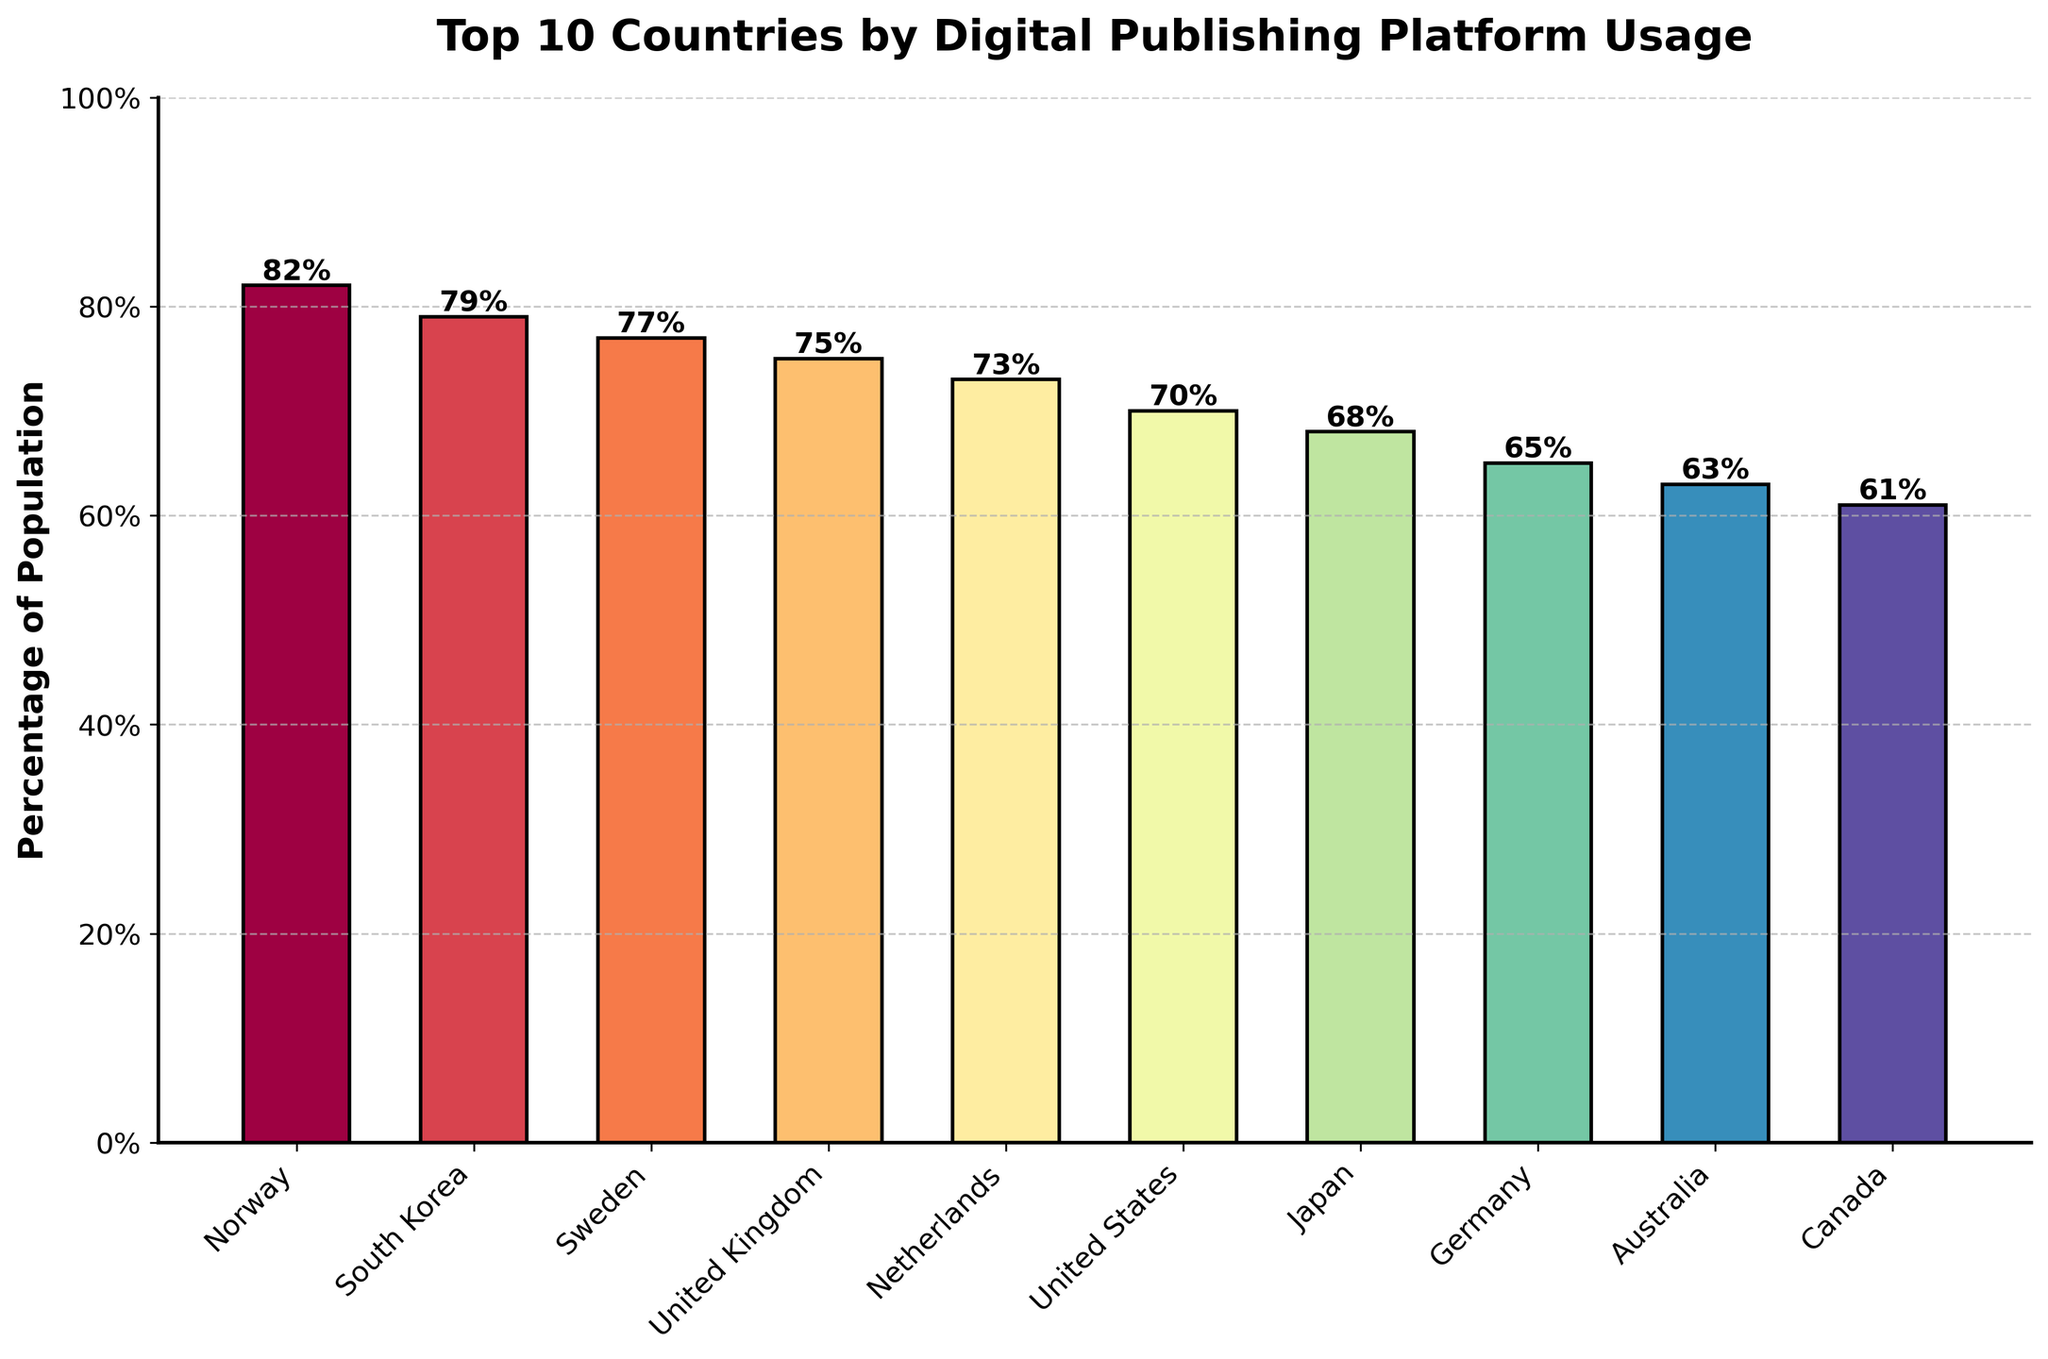What is the percentage of Norway's population using digital publishing platforms? The bar representing Norway's population usage is the tallest and is labeled with a percentage of 82%.
Answer: 82% What is the difference in digital publishing platform usage between Norway and Canada? Norway has a percentage of 82%, and Canada has 61%. The difference is calculated as 82% - 61% = 21%.
Answer: 21% Which country has the lowest percentage of population using digital publishing platforms? By observing the shortest bar, we see it corresponds to Canada with a percentage of 61%.
Answer: Canada Are there more countries with a usage percentage above 70% or below 70%? List the countries above 70%: Norway, South Korea, Sweden, United Kingdom, Netherlands, United States (6 countries). List the countries below 70%: Japan, Germany, Australia, Canada (4 countries). There are more countries above 70%.
Answer: Above 70% How many countries have a digital publishing platform usage between 60% and 80%? By examining the bar lengths and labels, countries with usage percentages between 60% and 80% are South Korea, Sweden, United Kingdom, Netherlands, United States, Japan, Germany, and Australia (8 countries).
Answer: 8 What is the average percentage of population using digital publishing platforms among the top 3 countries? The top 3 countries are Norway (82%), South Korea (79%), and Sweden (77%). Sum these percentages: 82 + 79 + 77 = 238. Calculate the average: 238 / 3 ≈ 79.33.
Answer: 79.33 Which country has a higher digital publishing platform usage, Germany or Australia? By comparing the bars and labels, Germany has 65% while Australia has 63%. Therefore, Germany has a higher usage percentage.
Answer: Germany What is the combined digital publishing platform usage percentage of the United Kingdom and the Netherlands? The usage percentage for the United Kingdom is 75% and for the Netherlands is 73%. Combined, it is 75% + 73% = 148%.
Answer: 148% Which countries have a usage percentage exactly 75% or higher? From the bars and labels, the countries with 75% or higher are Norway (82%), South Korea (79%), Sweden (77%), and the United Kingdom (75%).
Answer: Norway, South Korea, Sweden, United Kingdom What is the range of the digital publishing platform usage percentages among the listed countries? The highest percentage is from Norway (82%) and the lowest is from Canada (61%). The range is calculated as 82% - 61% = 21%.
Answer: 21% 